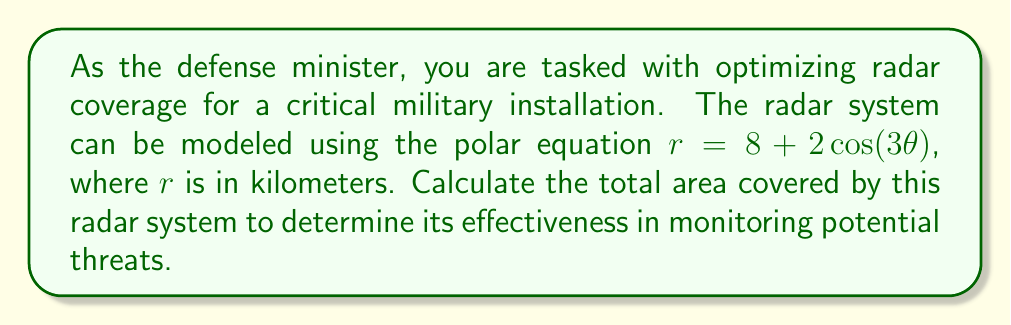Teach me how to tackle this problem. To solve this problem, we need to follow these steps:

1) The area of a region bounded by a polar curve is given by the formula:

   $$A = \frac{1}{2} \int_{0}^{2\pi} r^2 d\theta$$

2) In this case, $r = 8 + 2\cos(3\theta)$. We need to square this:

   $$r^2 = (8 + 2\cos(3\theta))^2 = 64 + 32\cos(3\theta) + 4\cos^2(3\theta)$$

3) Now, we can set up our integral:

   $$A = \frac{1}{2} \int_{0}^{2\pi} (64 + 32\cos(3\theta) + 4\cos^2(3\theta)) d\theta$$

4) Let's integrate each term separately:

   a) $\int_{0}^{2\pi} 64 d\theta = 64\theta \Big|_{0}^{2\pi} = 128\pi$

   b) $\int_{0}^{2\pi} 32\cos(3\theta) d\theta = \frac{32}{3}\sin(3\theta) \Big|_{0}^{2\pi} = 0$

   c) For the $\cos^2$ term, we can use the identity $\cos^2x = \frac{1}{2}(1 + \cos(2x))$:

      $\int_{0}^{2\pi} 4\cos^2(3\theta) d\theta = \int_{0}^{2\pi} 2(1 + \cos(6\theta)) d\theta$
      
      $= 2\theta + \frac{1}{3}\sin(6\theta) \Big|_{0}^{2\pi} = 4\pi$

5) Adding these results:

   $$A = \frac{1}{2}(128\pi + 0 + 4\pi) = 66\pi$$

Therefore, the total area covered by the radar system is $66\pi$ square kilometers.
Answer: $66\pi$ square kilometers 